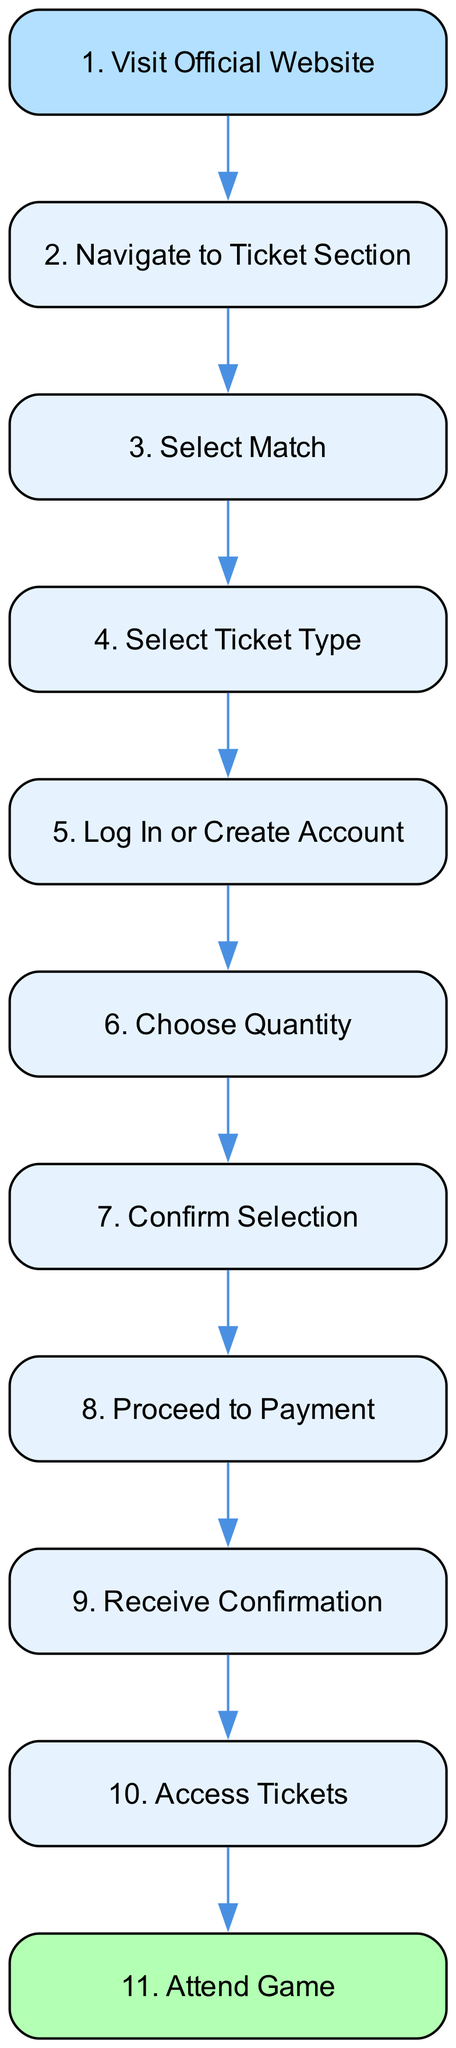What is the first step to purchase tickets? The first step in the diagram is labeled "Visit Official Website." This directs users to where they start the ticket purchase process.
Answer: Visit Official Website How many steps are involved in the ticket purchasing process? By counting the steps in the diagram, there are a total of 11 distinct steps listed, from visiting the website to attending the game.
Answer: 11 What do you need to do after selecting the match? After selecting the match, the next step indicates that you need to "Select Ticket Type," which is where you choose your desired ticket category.
Answer: Select Ticket Type What payment methods are accepted according to the diagram? In the step detailed as "Proceed to Payment," it states that accepted payment methods include credit/debit cards and bank transfers.
Answer: Credit/debit card and bank transfer Which step comes immediately before "Receive Confirmation"? The step immediately preceding "Receive Confirmation" is "Proceed to Payment," where users finalize their purchases before receiving the confirmation.
Answer: Proceed to Payment What type of tickets can you select? The diagram specifies that you can choose from General Admission, Preferred Seating, and VIP when selecting your ticket type.
Answer: General Admission, Preferred Seating, and VIP What is the last step in the ticket purchasing process? The final step in the ticket purchasing flow indicates "Attend Game," which is when you bring your tickets to the stadium on game day.
Answer: Attend Game What should you do if you don’t have an account? If you don’t have an account, the diagram instructs you to "Log In or Create Account," which is a necessary step before proceeding with the purchase.
Answer: Log In or Create Account What is required before confirming your selection? Before confirming your selection, you need to "Choose Quantity," where you select the number of tickets you wish to purchase.
Answer: Choose Quantity 